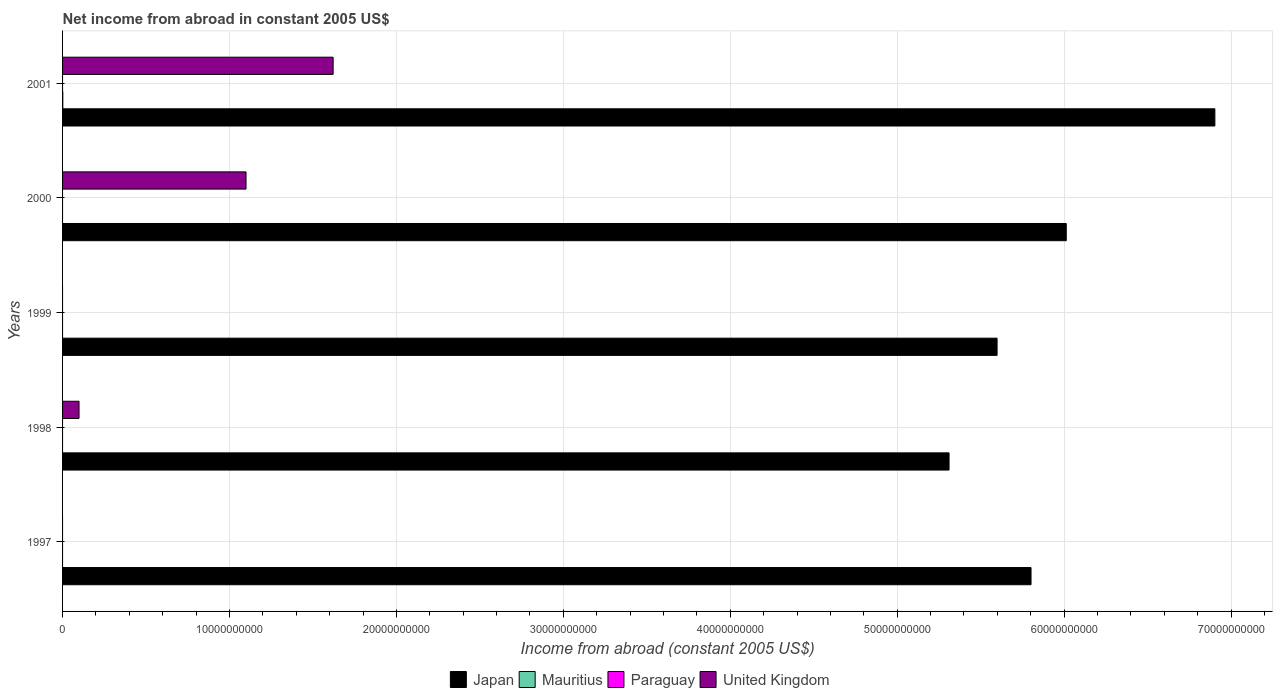How many bars are there on the 2nd tick from the bottom?
Provide a succinct answer. 2. What is the label of the 4th group of bars from the top?
Your answer should be compact. 1998. In how many cases, is the number of bars for a given year not equal to the number of legend labels?
Offer a very short reply. 5. What is the net income from abroad in United Kingdom in 2000?
Keep it short and to the point. 1.10e+1. Across all years, what is the maximum net income from abroad in Japan?
Provide a succinct answer. 6.90e+1. Across all years, what is the minimum net income from abroad in Mauritius?
Provide a short and direct response. 0. What is the total net income from abroad in Mauritius in the graph?
Your response must be concise. 1.35e+07. What is the difference between the net income from abroad in Japan in 1999 and that in 2001?
Your answer should be very brief. -1.30e+1. What is the difference between the net income from abroad in Paraguay in 1999 and the net income from abroad in Mauritius in 2001?
Your answer should be very brief. -1.35e+07. What is the average net income from abroad in Japan per year?
Your answer should be compact. 5.93e+1. In the year 2001, what is the difference between the net income from abroad in United Kingdom and net income from abroad in Japan?
Offer a terse response. -5.28e+1. What is the ratio of the net income from abroad in Japan in 1998 to that in 1999?
Offer a very short reply. 0.95. Is the net income from abroad in Japan in 1998 less than that in 1999?
Provide a succinct answer. Yes. Is the difference between the net income from abroad in United Kingdom in 1998 and 2000 greater than the difference between the net income from abroad in Japan in 1998 and 2000?
Your answer should be very brief. No. What is the difference between the highest and the second highest net income from abroad in Japan?
Your answer should be compact. 8.90e+09. What is the difference between the highest and the lowest net income from abroad in Japan?
Your answer should be compact. 1.59e+1. Is the sum of the net income from abroad in Japan in 1997 and 2000 greater than the maximum net income from abroad in Paraguay across all years?
Your answer should be very brief. Yes. Is it the case that in every year, the sum of the net income from abroad in Japan and net income from abroad in Mauritius is greater than the sum of net income from abroad in Paraguay and net income from abroad in United Kingdom?
Ensure brevity in your answer.  No. Is it the case that in every year, the sum of the net income from abroad in Paraguay and net income from abroad in Mauritius is greater than the net income from abroad in United Kingdom?
Your answer should be very brief. No. Are all the bars in the graph horizontal?
Your response must be concise. Yes. How many years are there in the graph?
Your response must be concise. 5. How are the legend labels stacked?
Offer a very short reply. Horizontal. What is the title of the graph?
Make the answer very short. Net income from abroad in constant 2005 US$. Does "Togo" appear as one of the legend labels in the graph?
Offer a very short reply. No. What is the label or title of the X-axis?
Give a very brief answer. Income from abroad (constant 2005 US$). What is the Income from abroad (constant 2005 US$) of Japan in 1997?
Your response must be concise. 5.80e+1. What is the Income from abroad (constant 2005 US$) of Mauritius in 1997?
Provide a short and direct response. 0. What is the Income from abroad (constant 2005 US$) of United Kingdom in 1997?
Keep it short and to the point. 0. What is the Income from abroad (constant 2005 US$) of Japan in 1998?
Make the answer very short. 5.31e+1. What is the Income from abroad (constant 2005 US$) in Paraguay in 1998?
Your answer should be very brief. 0. What is the Income from abroad (constant 2005 US$) in United Kingdom in 1998?
Give a very brief answer. 9.86e+08. What is the Income from abroad (constant 2005 US$) of Japan in 1999?
Offer a terse response. 5.60e+1. What is the Income from abroad (constant 2005 US$) of Mauritius in 1999?
Provide a succinct answer. 0. What is the Income from abroad (constant 2005 US$) in Paraguay in 1999?
Your answer should be compact. 0. What is the Income from abroad (constant 2005 US$) in Japan in 2000?
Give a very brief answer. 6.01e+1. What is the Income from abroad (constant 2005 US$) of Mauritius in 2000?
Give a very brief answer. 0. What is the Income from abroad (constant 2005 US$) of United Kingdom in 2000?
Make the answer very short. 1.10e+1. What is the Income from abroad (constant 2005 US$) of Japan in 2001?
Provide a short and direct response. 6.90e+1. What is the Income from abroad (constant 2005 US$) of Mauritius in 2001?
Offer a terse response. 1.35e+07. What is the Income from abroad (constant 2005 US$) in Paraguay in 2001?
Offer a terse response. 0. What is the Income from abroad (constant 2005 US$) in United Kingdom in 2001?
Offer a very short reply. 1.62e+1. Across all years, what is the maximum Income from abroad (constant 2005 US$) of Japan?
Make the answer very short. 6.90e+1. Across all years, what is the maximum Income from abroad (constant 2005 US$) in Mauritius?
Give a very brief answer. 1.35e+07. Across all years, what is the maximum Income from abroad (constant 2005 US$) in United Kingdom?
Your answer should be compact. 1.62e+1. Across all years, what is the minimum Income from abroad (constant 2005 US$) of Japan?
Your answer should be compact. 5.31e+1. Across all years, what is the minimum Income from abroad (constant 2005 US$) of Mauritius?
Offer a terse response. 0. What is the total Income from abroad (constant 2005 US$) of Japan in the graph?
Make the answer very short. 2.96e+11. What is the total Income from abroad (constant 2005 US$) in Mauritius in the graph?
Make the answer very short. 1.35e+07. What is the total Income from abroad (constant 2005 US$) in United Kingdom in the graph?
Your answer should be very brief. 2.82e+1. What is the difference between the Income from abroad (constant 2005 US$) in Japan in 1997 and that in 1998?
Your answer should be very brief. 4.91e+09. What is the difference between the Income from abroad (constant 2005 US$) of Japan in 1997 and that in 1999?
Your response must be concise. 2.03e+09. What is the difference between the Income from abroad (constant 2005 US$) of Japan in 1997 and that in 2000?
Make the answer very short. -2.11e+09. What is the difference between the Income from abroad (constant 2005 US$) in Japan in 1997 and that in 2001?
Give a very brief answer. -1.10e+1. What is the difference between the Income from abroad (constant 2005 US$) of Japan in 1998 and that in 1999?
Provide a succinct answer. -2.88e+09. What is the difference between the Income from abroad (constant 2005 US$) of Japan in 1998 and that in 2000?
Make the answer very short. -7.02e+09. What is the difference between the Income from abroad (constant 2005 US$) of United Kingdom in 1998 and that in 2000?
Keep it short and to the point. -1.00e+1. What is the difference between the Income from abroad (constant 2005 US$) in Japan in 1998 and that in 2001?
Your answer should be very brief. -1.59e+1. What is the difference between the Income from abroad (constant 2005 US$) of United Kingdom in 1998 and that in 2001?
Provide a succinct answer. -1.52e+1. What is the difference between the Income from abroad (constant 2005 US$) of Japan in 1999 and that in 2000?
Ensure brevity in your answer.  -4.14e+09. What is the difference between the Income from abroad (constant 2005 US$) of Japan in 1999 and that in 2001?
Your answer should be compact. -1.30e+1. What is the difference between the Income from abroad (constant 2005 US$) of Japan in 2000 and that in 2001?
Your answer should be compact. -8.90e+09. What is the difference between the Income from abroad (constant 2005 US$) in United Kingdom in 2000 and that in 2001?
Give a very brief answer. -5.22e+09. What is the difference between the Income from abroad (constant 2005 US$) of Japan in 1997 and the Income from abroad (constant 2005 US$) of United Kingdom in 1998?
Your answer should be compact. 5.70e+1. What is the difference between the Income from abroad (constant 2005 US$) in Japan in 1997 and the Income from abroad (constant 2005 US$) in United Kingdom in 2000?
Make the answer very short. 4.70e+1. What is the difference between the Income from abroad (constant 2005 US$) in Japan in 1997 and the Income from abroad (constant 2005 US$) in Mauritius in 2001?
Keep it short and to the point. 5.80e+1. What is the difference between the Income from abroad (constant 2005 US$) in Japan in 1997 and the Income from abroad (constant 2005 US$) in United Kingdom in 2001?
Offer a terse response. 4.18e+1. What is the difference between the Income from abroad (constant 2005 US$) in Japan in 1998 and the Income from abroad (constant 2005 US$) in United Kingdom in 2000?
Provide a succinct answer. 4.21e+1. What is the difference between the Income from abroad (constant 2005 US$) of Japan in 1998 and the Income from abroad (constant 2005 US$) of Mauritius in 2001?
Offer a very short reply. 5.31e+1. What is the difference between the Income from abroad (constant 2005 US$) in Japan in 1998 and the Income from abroad (constant 2005 US$) in United Kingdom in 2001?
Ensure brevity in your answer.  3.69e+1. What is the difference between the Income from abroad (constant 2005 US$) in Japan in 1999 and the Income from abroad (constant 2005 US$) in United Kingdom in 2000?
Make the answer very short. 4.50e+1. What is the difference between the Income from abroad (constant 2005 US$) of Japan in 1999 and the Income from abroad (constant 2005 US$) of Mauritius in 2001?
Provide a succinct answer. 5.60e+1. What is the difference between the Income from abroad (constant 2005 US$) in Japan in 1999 and the Income from abroad (constant 2005 US$) in United Kingdom in 2001?
Give a very brief answer. 3.98e+1. What is the difference between the Income from abroad (constant 2005 US$) of Japan in 2000 and the Income from abroad (constant 2005 US$) of Mauritius in 2001?
Provide a succinct answer. 6.01e+1. What is the difference between the Income from abroad (constant 2005 US$) of Japan in 2000 and the Income from abroad (constant 2005 US$) of United Kingdom in 2001?
Keep it short and to the point. 4.39e+1. What is the average Income from abroad (constant 2005 US$) in Japan per year?
Offer a very short reply. 5.93e+1. What is the average Income from abroad (constant 2005 US$) in Mauritius per year?
Provide a succinct answer. 2.70e+06. What is the average Income from abroad (constant 2005 US$) in United Kingdom per year?
Offer a terse response. 5.64e+09. In the year 1998, what is the difference between the Income from abroad (constant 2005 US$) in Japan and Income from abroad (constant 2005 US$) in United Kingdom?
Keep it short and to the point. 5.21e+1. In the year 2000, what is the difference between the Income from abroad (constant 2005 US$) in Japan and Income from abroad (constant 2005 US$) in United Kingdom?
Ensure brevity in your answer.  4.91e+1. In the year 2001, what is the difference between the Income from abroad (constant 2005 US$) in Japan and Income from abroad (constant 2005 US$) in Mauritius?
Provide a short and direct response. 6.90e+1. In the year 2001, what is the difference between the Income from abroad (constant 2005 US$) in Japan and Income from abroad (constant 2005 US$) in United Kingdom?
Offer a very short reply. 5.28e+1. In the year 2001, what is the difference between the Income from abroad (constant 2005 US$) of Mauritius and Income from abroad (constant 2005 US$) of United Kingdom?
Provide a short and direct response. -1.62e+1. What is the ratio of the Income from abroad (constant 2005 US$) of Japan in 1997 to that in 1998?
Provide a succinct answer. 1.09. What is the ratio of the Income from abroad (constant 2005 US$) of Japan in 1997 to that in 1999?
Give a very brief answer. 1.04. What is the ratio of the Income from abroad (constant 2005 US$) of Japan in 1997 to that in 2000?
Your answer should be very brief. 0.96. What is the ratio of the Income from abroad (constant 2005 US$) in Japan in 1997 to that in 2001?
Keep it short and to the point. 0.84. What is the ratio of the Income from abroad (constant 2005 US$) in Japan in 1998 to that in 1999?
Ensure brevity in your answer.  0.95. What is the ratio of the Income from abroad (constant 2005 US$) of Japan in 1998 to that in 2000?
Provide a short and direct response. 0.88. What is the ratio of the Income from abroad (constant 2005 US$) of United Kingdom in 1998 to that in 2000?
Your answer should be very brief. 0.09. What is the ratio of the Income from abroad (constant 2005 US$) in Japan in 1998 to that in 2001?
Make the answer very short. 0.77. What is the ratio of the Income from abroad (constant 2005 US$) in United Kingdom in 1998 to that in 2001?
Provide a succinct answer. 0.06. What is the ratio of the Income from abroad (constant 2005 US$) in Japan in 1999 to that in 2000?
Offer a terse response. 0.93. What is the ratio of the Income from abroad (constant 2005 US$) of Japan in 1999 to that in 2001?
Give a very brief answer. 0.81. What is the ratio of the Income from abroad (constant 2005 US$) of Japan in 2000 to that in 2001?
Keep it short and to the point. 0.87. What is the ratio of the Income from abroad (constant 2005 US$) of United Kingdom in 2000 to that in 2001?
Ensure brevity in your answer.  0.68. What is the difference between the highest and the second highest Income from abroad (constant 2005 US$) of Japan?
Offer a very short reply. 8.90e+09. What is the difference between the highest and the second highest Income from abroad (constant 2005 US$) of United Kingdom?
Make the answer very short. 5.22e+09. What is the difference between the highest and the lowest Income from abroad (constant 2005 US$) in Japan?
Ensure brevity in your answer.  1.59e+1. What is the difference between the highest and the lowest Income from abroad (constant 2005 US$) of Mauritius?
Offer a very short reply. 1.35e+07. What is the difference between the highest and the lowest Income from abroad (constant 2005 US$) of United Kingdom?
Give a very brief answer. 1.62e+1. 